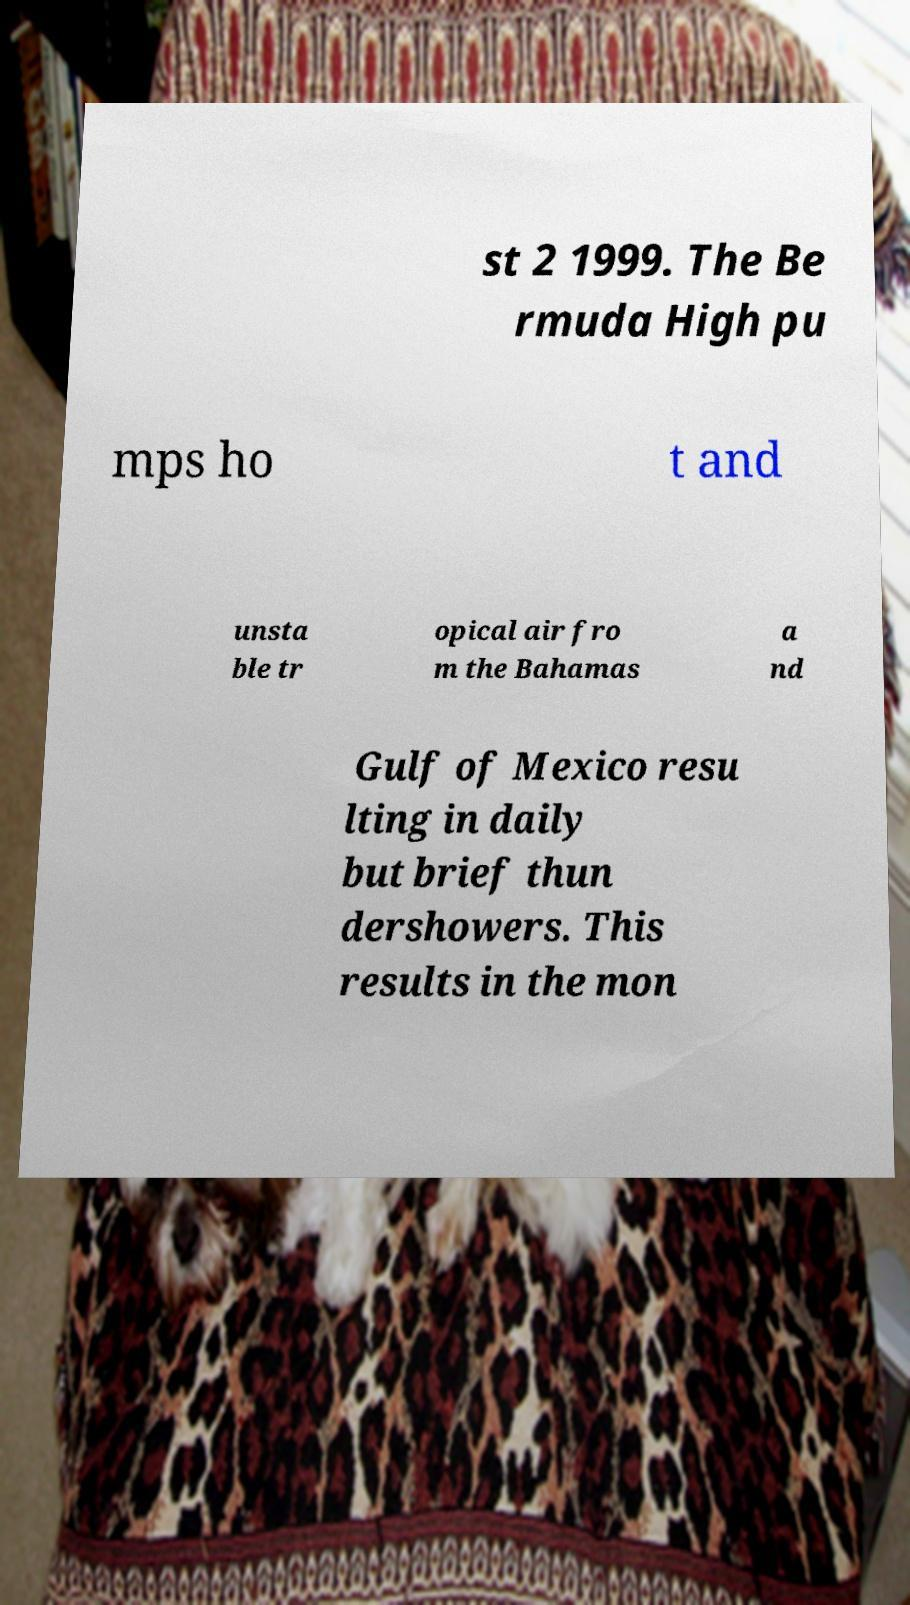What messages or text are displayed in this image? I need them in a readable, typed format. st 2 1999. The Be rmuda High pu mps ho t and unsta ble tr opical air fro m the Bahamas a nd Gulf of Mexico resu lting in daily but brief thun dershowers. This results in the mon 